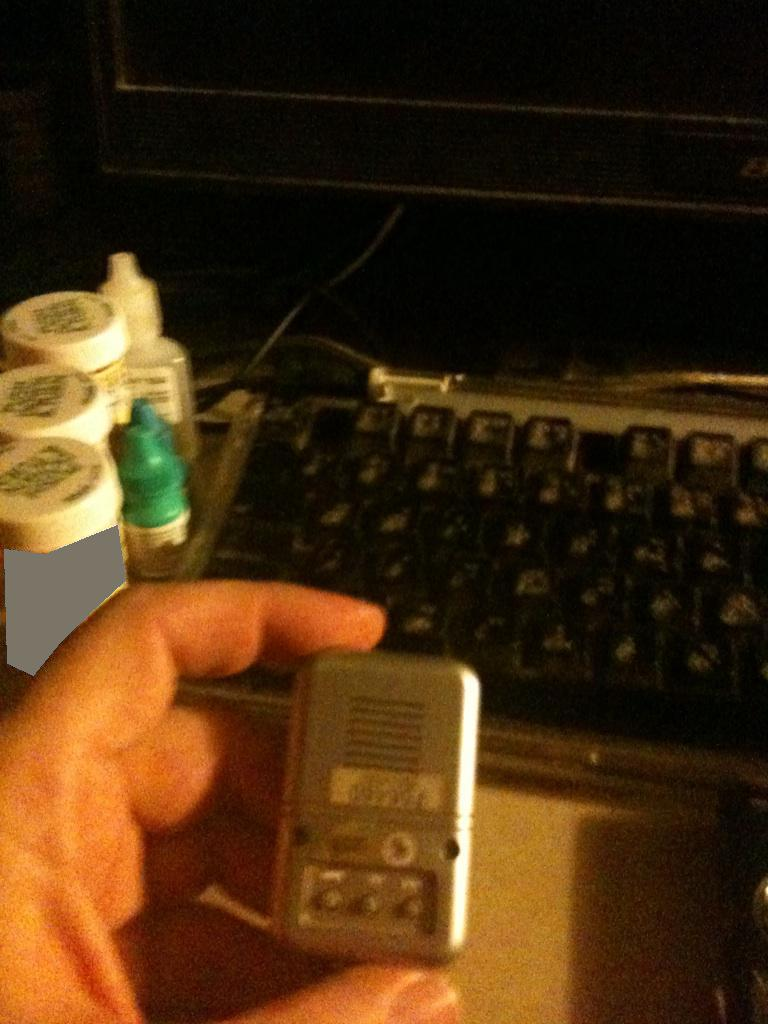Is the clock face visible? No, the clock face is not visible in the image. The image mainly shows a keyboard and some small containers, but no clock face is apparent. 